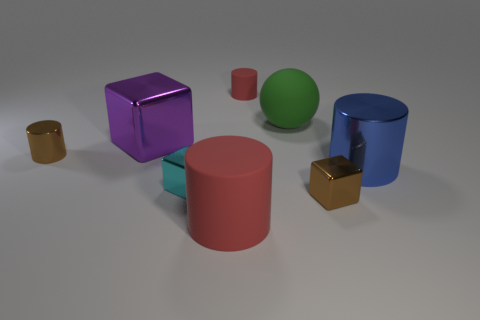There is a shiny object that is the same color as the small shiny cylinder; what is its shape? cube 